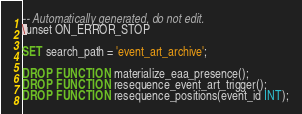<code> <loc_0><loc_0><loc_500><loc_500><_SQL_>-- Automatically generated, do not edit.
\unset ON_ERROR_STOP

SET search_path = 'event_art_archive';

DROP FUNCTION materialize_eaa_presence();
DROP FUNCTION resequence_event_art_trigger();
DROP FUNCTION resequence_positions(event_id INT);
</code> 